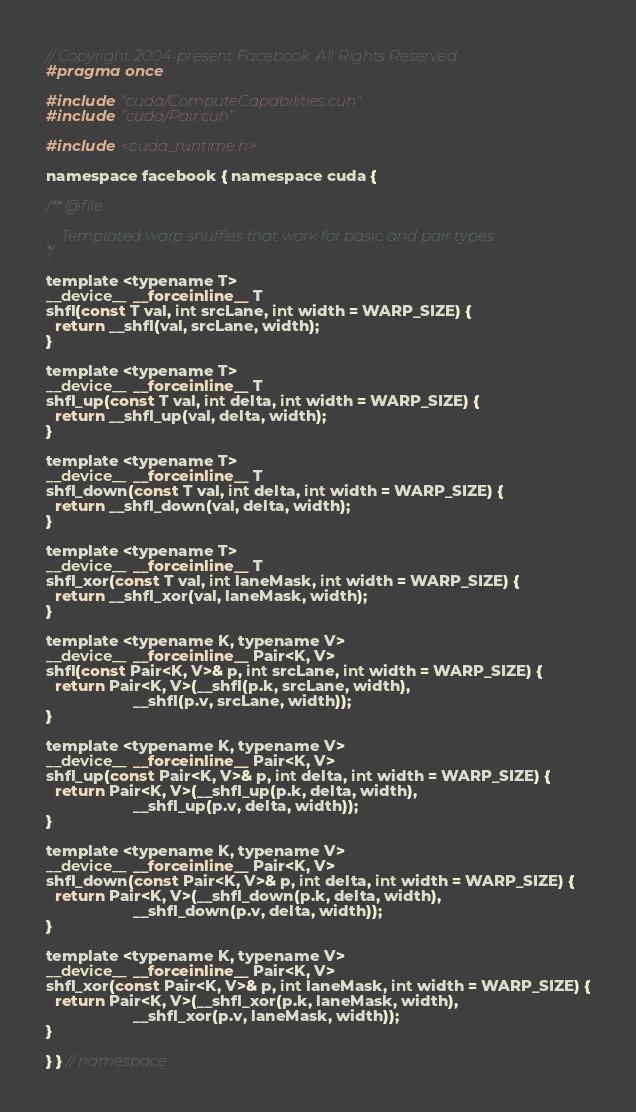<code> <loc_0><loc_0><loc_500><loc_500><_Cuda_>// Copyright 2004-present Facebook. All Rights Reserved.
#pragma once

#include "cuda/ComputeCapabilities.cuh"
#include "cuda/Pair.cuh"

#include <cuda_runtime.h>

namespace facebook { namespace cuda {

/** @file

    Templated warp shuffles that work for basic and pair types
*/

template <typename T>
__device__ __forceinline__ T
shfl(const T val, int srcLane, int width = WARP_SIZE) {
  return __shfl(val, srcLane, width);
}

template <typename T>
__device__ __forceinline__ T
shfl_up(const T val, int delta, int width = WARP_SIZE) {
  return __shfl_up(val, delta, width);
}

template <typename T>
__device__ __forceinline__ T
shfl_down(const T val, int delta, int width = WARP_SIZE) {
  return __shfl_down(val, delta, width);
}

template <typename T>
__device__ __forceinline__ T
shfl_xor(const T val, int laneMask, int width = WARP_SIZE) {
  return __shfl_xor(val, laneMask, width);
}

template <typename K, typename V>
__device__ __forceinline__ Pair<K, V>
shfl(const Pair<K, V>& p, int srcLane, int width = WARP_SIZE) {
  return Pair<K, V>(__shfl(p.k, srcLane, width),
                    __shfl(p.v, srcLane, width));
}

template <typename K, typename V>
__device__ __forceinline__ Pair<K, V>
shfl_up(const Pair<K, V>& p, int delta, int width = WARP_SIZE) {
  return Pair<K, V>(__shfl_up(p.k, delta, width),
                    __shfl_up(p.v, delta, width));
}

template <typename K, typename V>
__device__ __forceinline__ Pair<K, V>
shfl_down(const Pair<K, V>& p, int delta, int width = WARP_SIZE) {
  return Pair<K, V>(__shfl_down(p.k, delta, width),
                    __shfl_down(p.v, delta, width));
}

template <typename K, typename V>
__device__ __forceinline__ Pair<K, V>
shfl_xor(const Pair<K, V>& p, int laneMask, int width = WARP_SIZE) {
  return Pair<K, V>(__shfl_xor(p.k, laneMask, width),
                    __shfl_xor(p.v, laneMask, width));
}

} } // namespace
</code> 